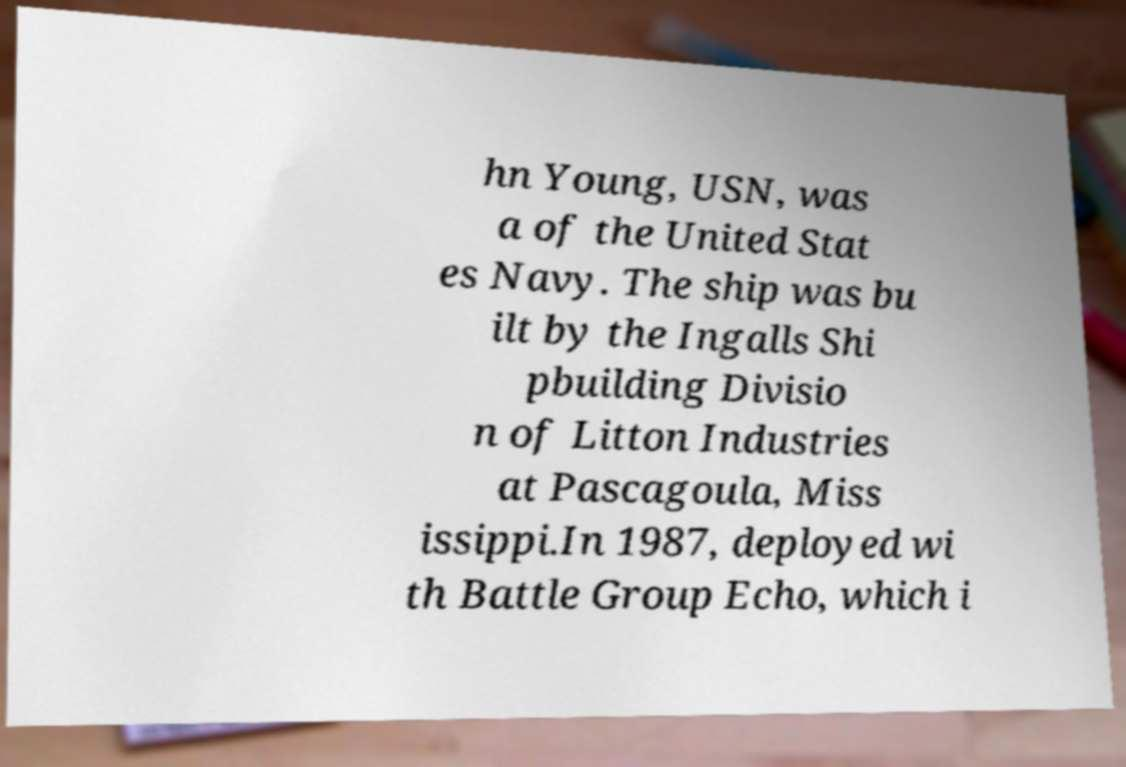Could you extract and type out the text from this image? hn Young, USN, was a of the United Stat es Navy. The ship was bu ilt by the Ingalls Shi pbuilding Divisio n of Litton Industries at Pascagoula, Miss issippi.In 1987, deployed wi th Battle Group Echo, which i 